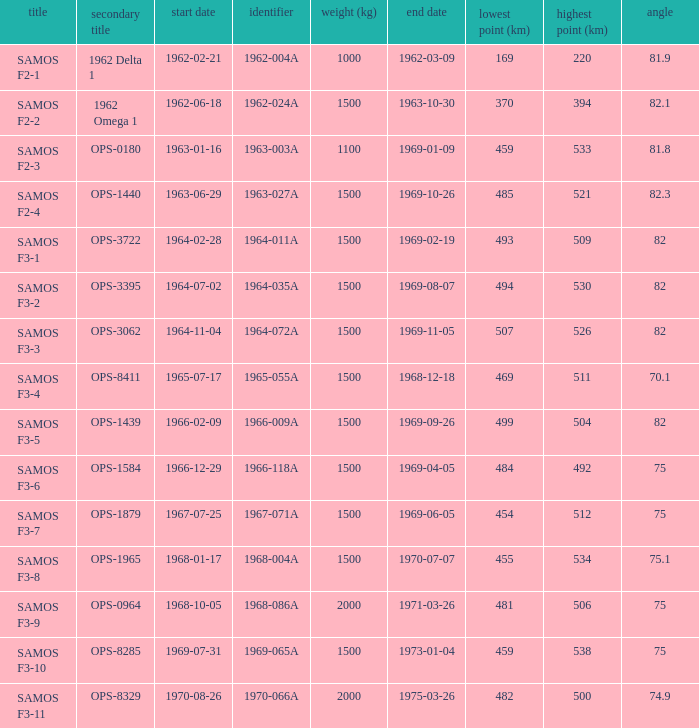How many alt names does 1964-011a have? 1.0. 